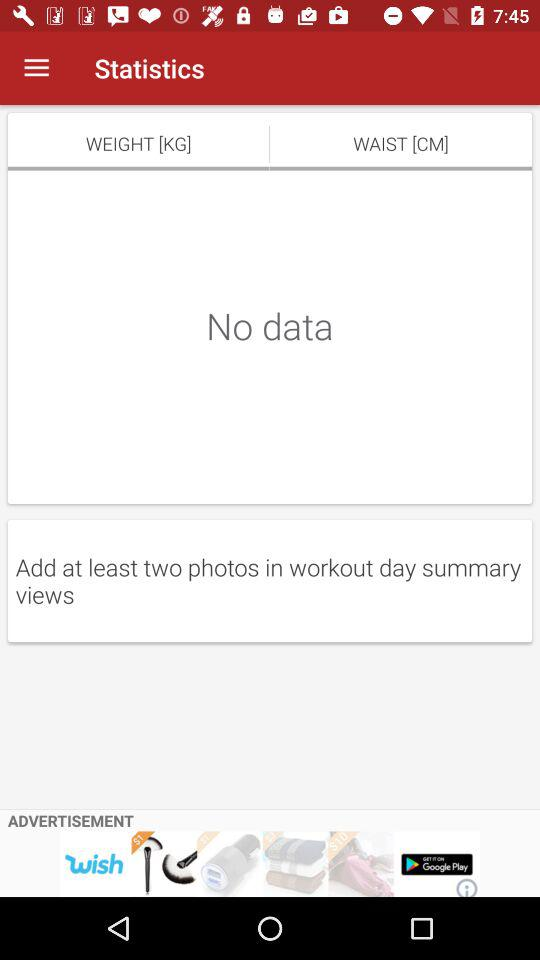What's the measuring unit of waist? The measuring unit is cm. 